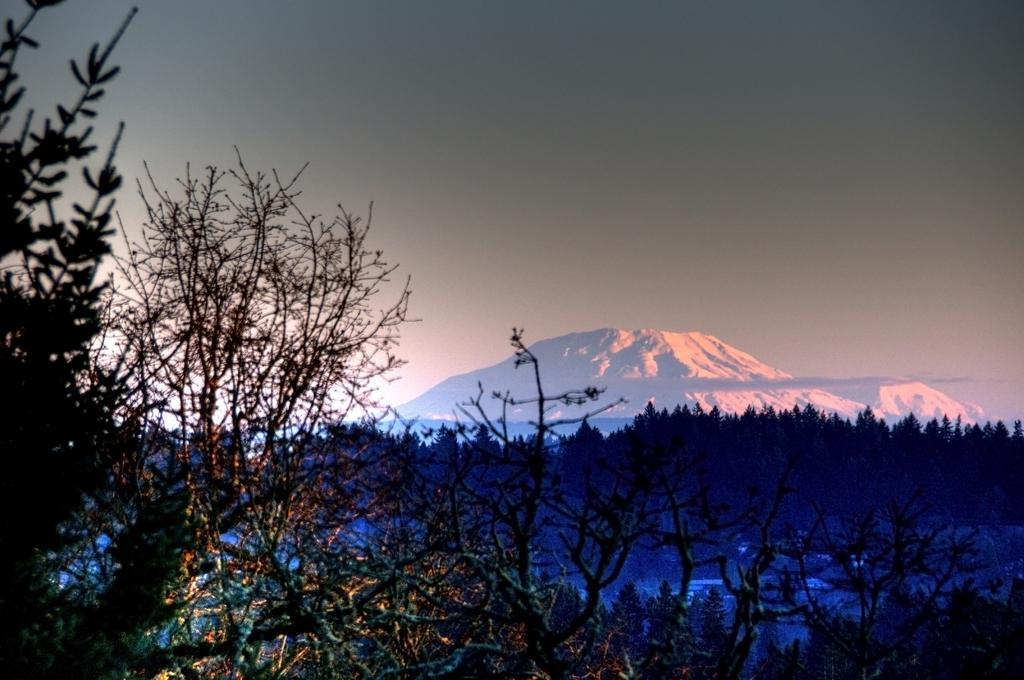What type of natural features can be seen in the image? There are trees and mountains in the image. What is visible at the top of the image? The sky is visible at the top of the image. How many snails can be seen climbing the trees in the image? There are no snails visible in the image; it features trees and mountains. What type of wheel is present in the image? There is no wheel present in the image. 